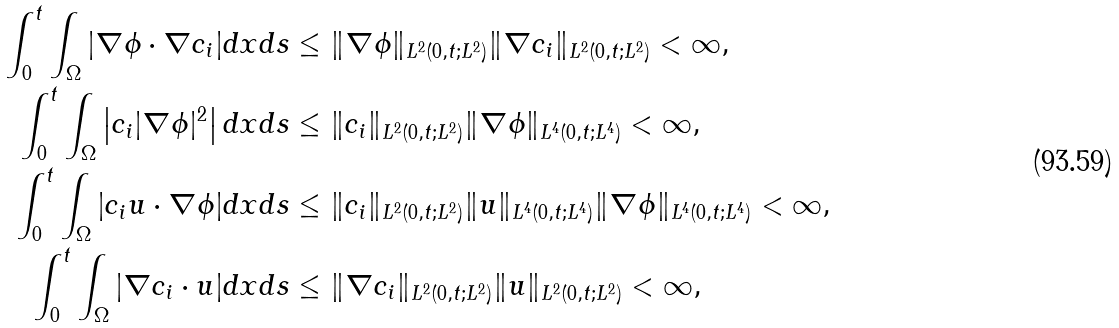<formula> <loc_0><loc_0><loc_500><loc_500>\int _ { 0 } ^ { t } \int _ { \Omega } | \nabla \phi \cdot \nabla c _ { i } | d x d s & \leq \| \nabla \phi \| _ { L ^ { 2 } ( 0 , t ; L ^ { 2 } ) } \| \nabla c _ { i } \| _ { L ^ { 2 } ( 0 , t ; L ^ { 2 } ) } < \infty , \\ \int _ { 0 } ^ { t } \int _ { \Omega } \left | c _ { i } | \nabla \phi | ^ { 2 } \right | d x d s & \leq \| c _ { i } \| _ { L ^ { 2 } ( 0 , t ; L ^ { 2 } ) } \| \nabla \phi \| _ { L ^ { 4 } ( 0 , t ; L ^ { 4 } ) } < \infty , \\ \int _ { 0 } ^ { t } \int _ { \Omega } | c _ { i } u \cdot \nabla \phi | d x d s & \leq \| c _ { i } \| _ { L ^ { 2 } ( 0 , t ; L ^ { 2 } ) } \| u \| _ { L ^ { 4 } ( 0 , t ; L ^ { 4 } ) } \| \nabla \phi \| _ { L ^ { 4 } ( 0 , t ; L ^ { 4 } ) } < \infty , \\ \int _ { 0 } ^ { t } \int _ { \Omega } | \nabla c _ { i } \cdot u | d x d s & \leq \| \nabla c _ { i } \| _ { L ^ { 2 } ( 0 , t ; L ^ { 2 } ) } \| u \| _ { L ^ { 2 } ( 0 , t ; L ^ { 2 } ) } < \infty ,</formula> 